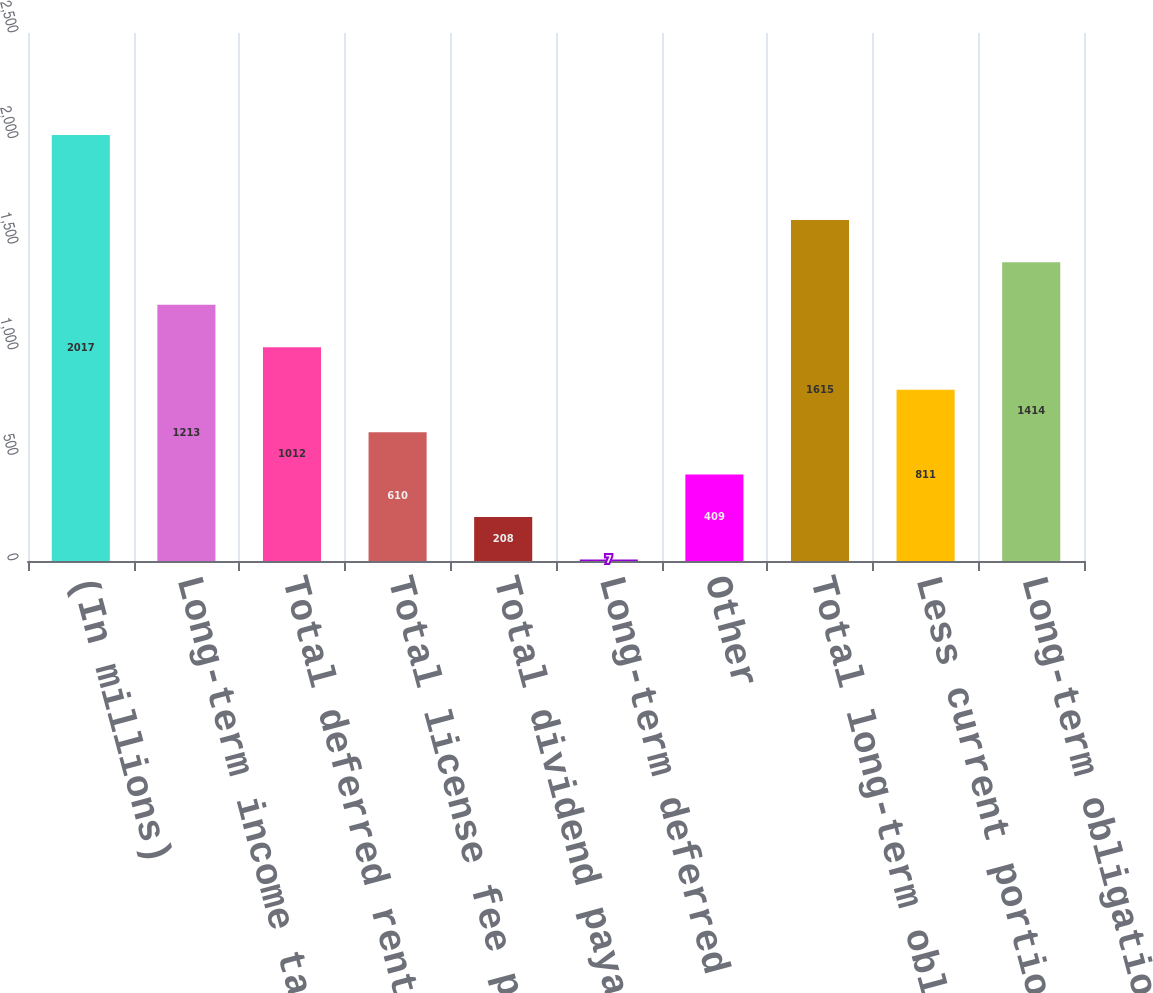<chart> <loc_0><loc_0><loc_500><loc_500><bar_chart><fcel>(In millions)<fcel>Long-term income tax<fcel>Total deferred rent<fcel>Total license fee payable<fcel>Total dividend payable<fcel>Long-term deferred income tax<fcel>Other<fcel>Total long-term obligations<fcel>Less current portion (included<fcel>Long-term obligations due<nl><fcel>2017<fcel>1213<fcel>1012<fcel>610<fcel>208<fcel>7<fcel>409<fcel>1615<fcel>811<fcel>1414<nl></chart> 